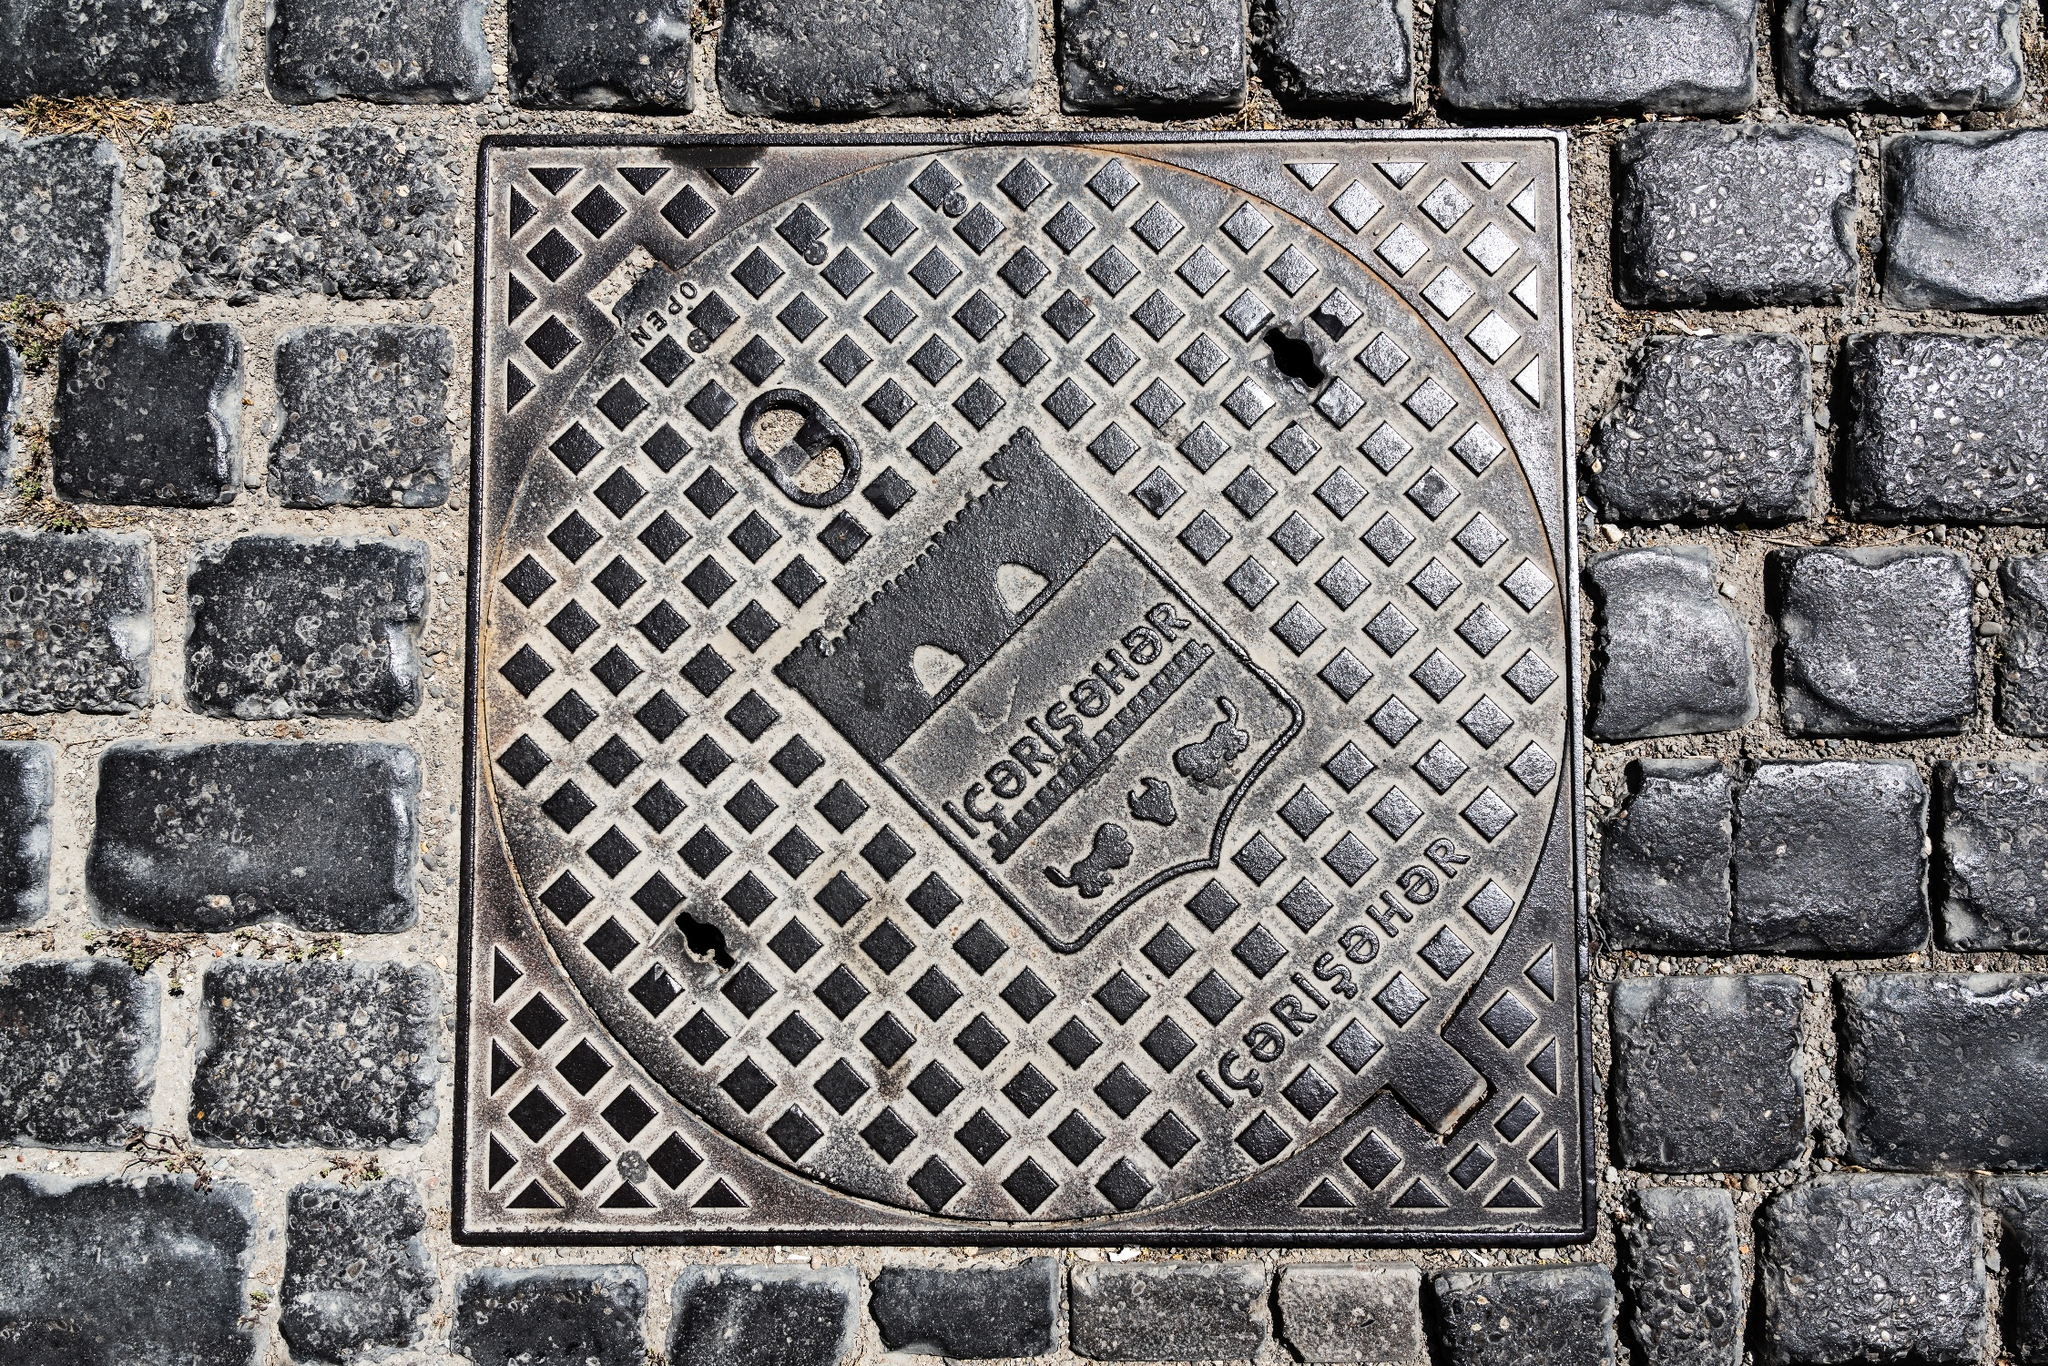How might the condition of this manhole cover and the surrounding cobbles inform us about this location's climate? The visible wear on the manhole cover, including rust and erosion, coupled with the moss growing between the cobblestones, suggests that the area experiences a climate with a fair amount of precipitation and possibly fluctuating temperatures. These conditions encourage both the oxidation of metal and the growth of moss, hinting at a temperate climate with damp conditions. 